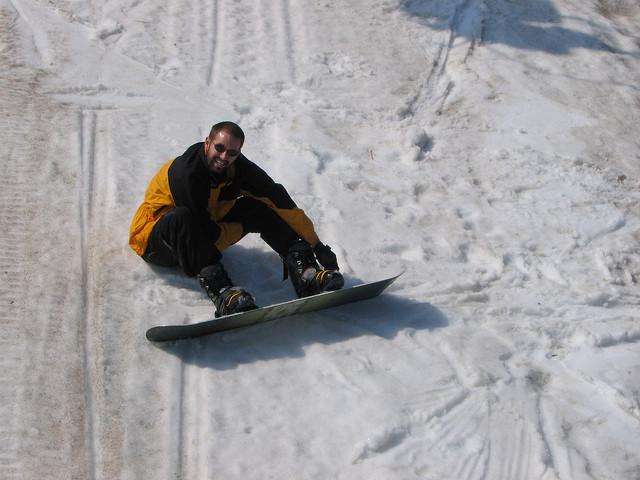What color is the snow?
Quick response, please. White. What is the man doing?
Give a very brief answer. Snowboarding. Does the man look happy?
Write a very short answer. Yes. Is this fresh powder?
Short answer required. No. 